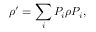Convert formula to latex. <formula><loc_0><loc_0><loc_500><loc_500>\rho ^ { \prime } = \sum _ { i } P _ { i } \rho P _ { i } ,</formula> 